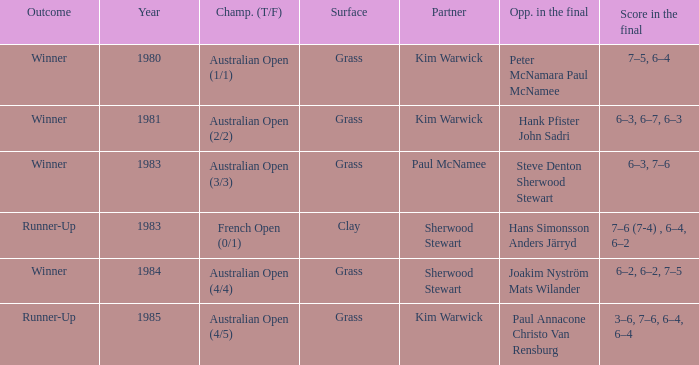How many different outcomes did the final with Paul McNamee as a partner have? 1.0. 